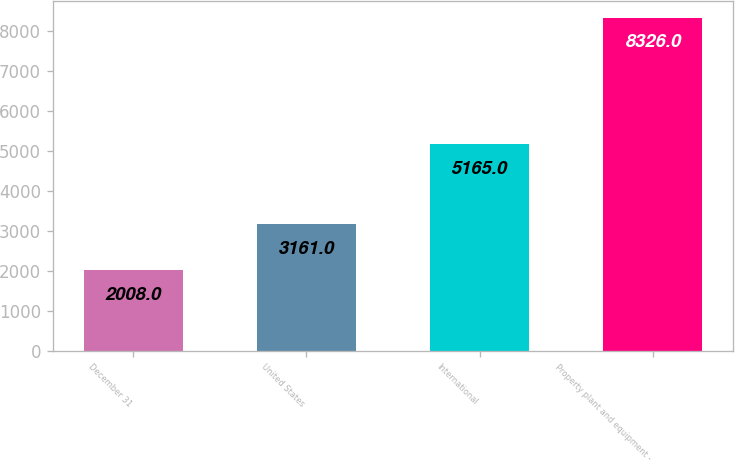<chart> <loc_0><loc_0><loc_500><loc_500><bar_chart><fcel>December 31<fcel>United States<fcel>International<fcel>Property plant and equipment -<nl><fcel>2008<fcel>3161<fcel>5165<fcel>8326<nl></chart> 